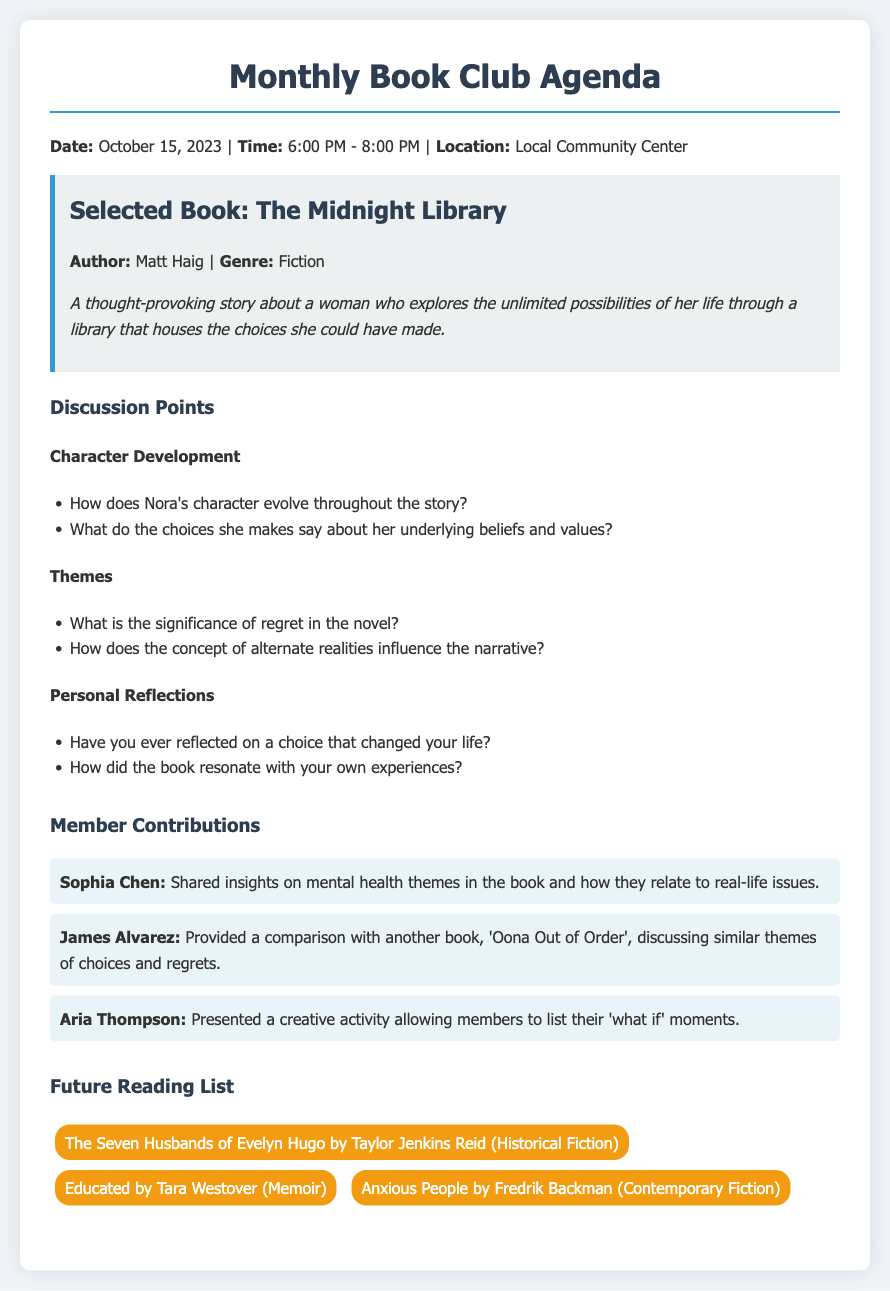What is the date of the book club meeting? The date is specified in the agenda as October 15, 2023.
Answer: October 15, 2023 Who is the author of the selected book? The author's name is mentioned in the book information section of the agenda.
Answer: Matt Haig What genre is "The Midnight Library"? The genre is noted in the book info as Fiction.
Answer: Fiction What theme does Sophia Chen discuss? Sophia Chen's contribution points to mental health themes in the book.
Answer: Mental health What activity did Aria Thompson present? Aria's contribution involved a creative activity about 'what if' moments.
Answer: Creative activity What is the name of the first future reading book? The future reading list starts with "The Seven Husbands of Evelyn Hugo".
Answer: The Seven Husbands of Evelyn Hugo How many members contributed to the discussion? The member contributions section lists three members, indicating who contributed.
Answer: Three What is the time of the meeting? The time for the meeting is provided in the introductory section of the agenda.
Answer: 6:00 PM - 8:00 PM What is one major theme discussed in the book? A major theme discussed is the significance of regret in the novel.
Answer: Regret 